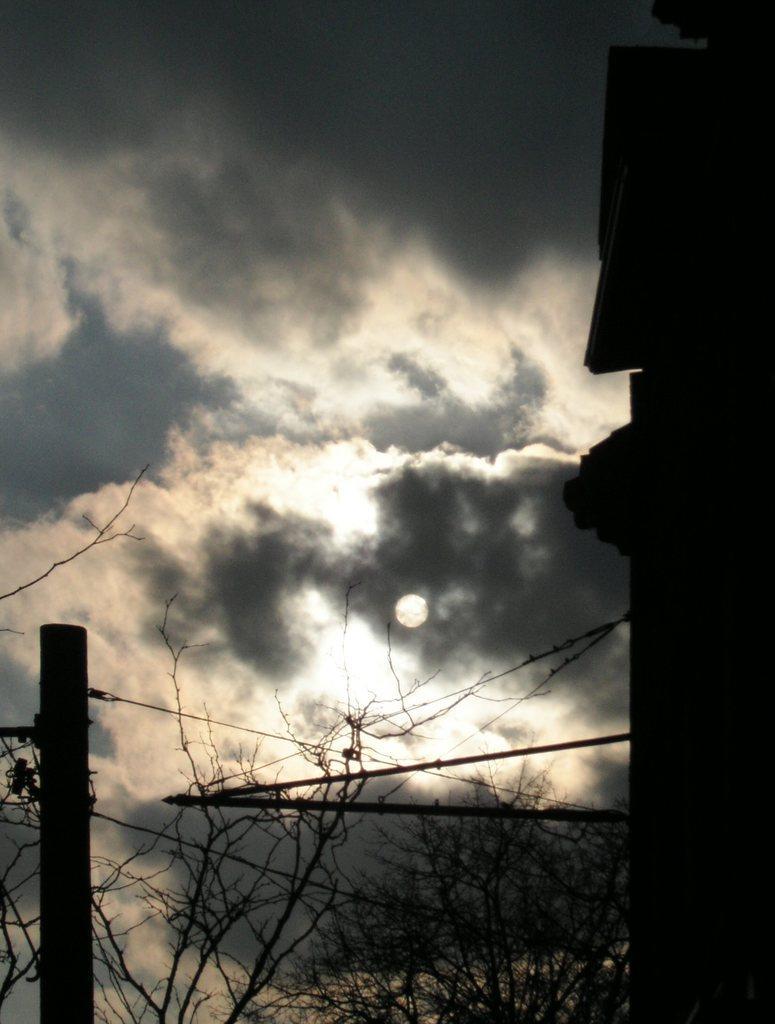Describe this image in one or two sentences. In the image in the center we can see the sky,clouds,trees,moon,pole and wall. 